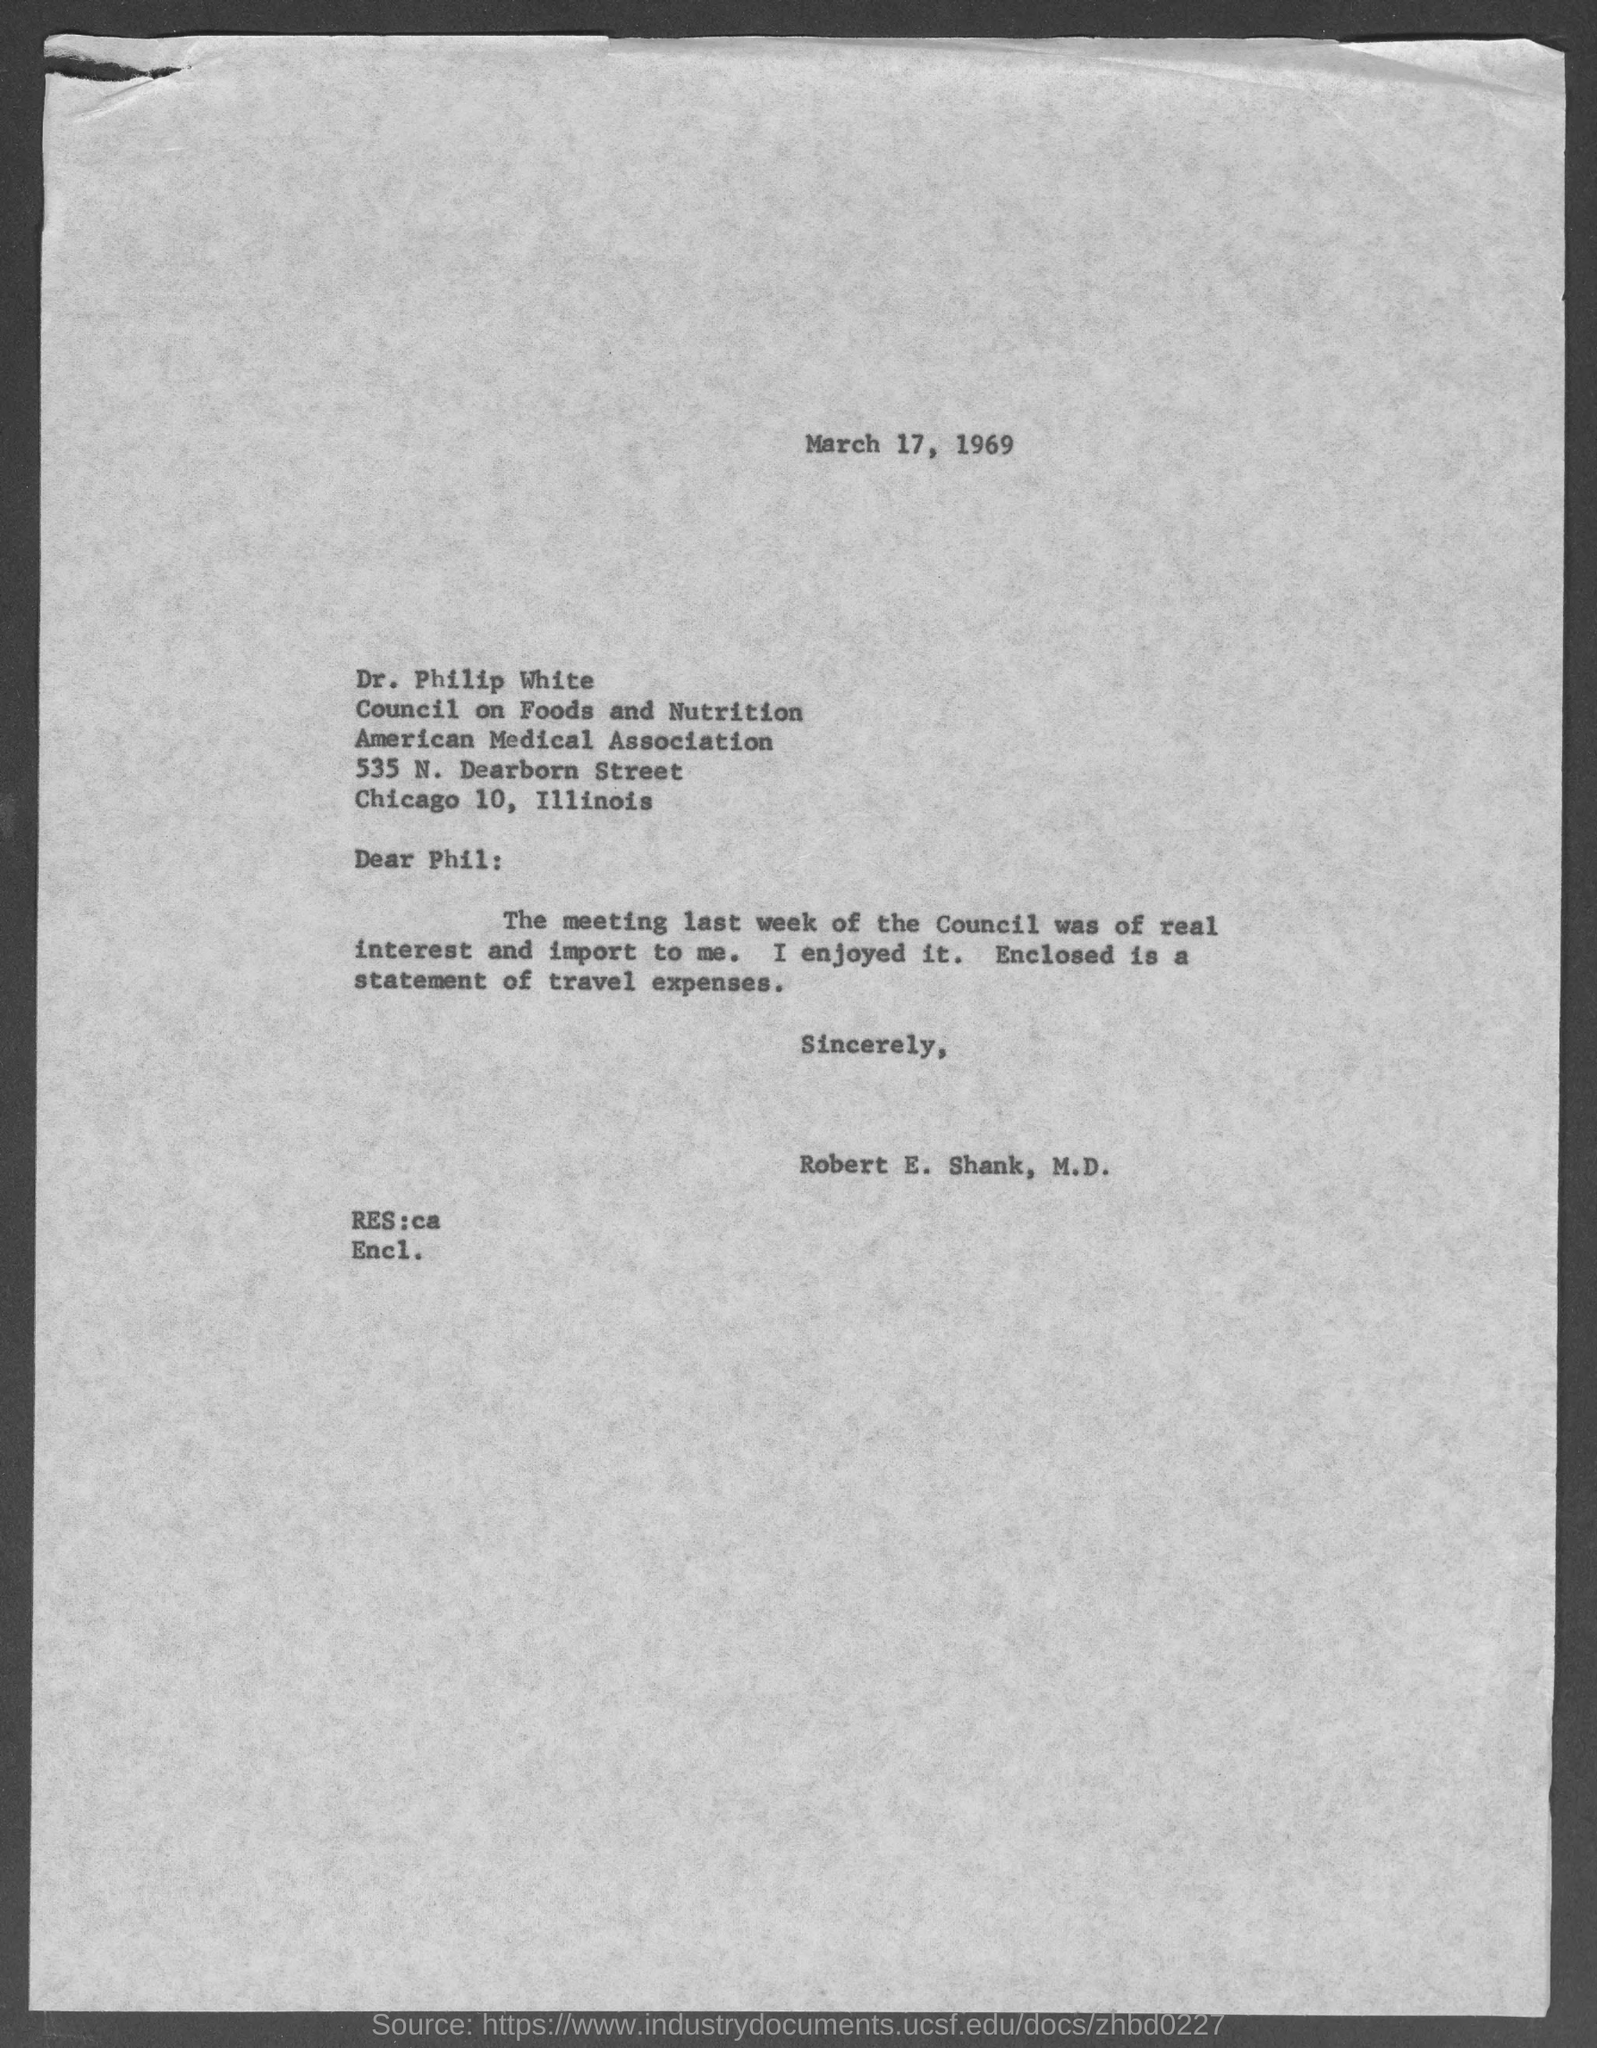When is the letter dated ?
Your response must be concise. March 17, 1969. In which city is american medical association at ?
Keep it short and to the point. Chicago 10. Who wrote this letter ?
Provide a succinct answer. Robert E. Shank, M.D. 